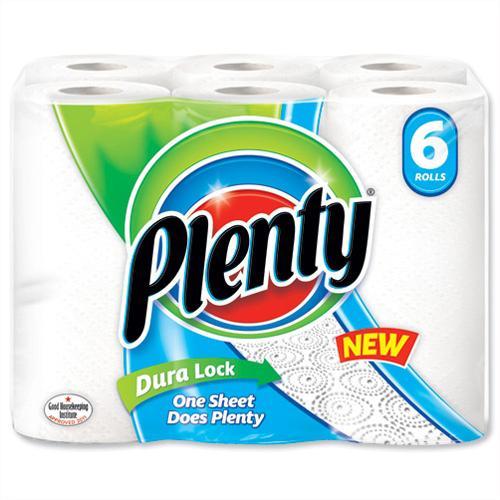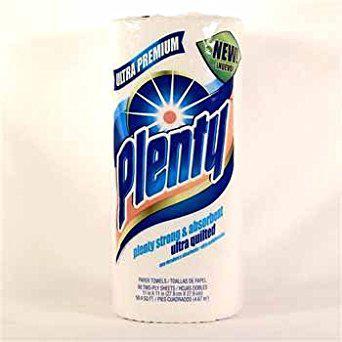The first image is the image on the left, the second image is the image on the right. Assess this claim about the two images: "Two packages of the same brand of multiple rolls of paper towels are shown, the smaller package with least two rolls, and the larger package at least twice as large as the smaller one.". Correct or not? Answer yes or no. No. The first image is the image on the left, the second image is the image on the right. Examine the images to the left and right. Is the description "The paper towel package on the left features an image of three colored concentric rings, and the package on the right features a sunburst image." accurate? Answer yes or no. Yes. 